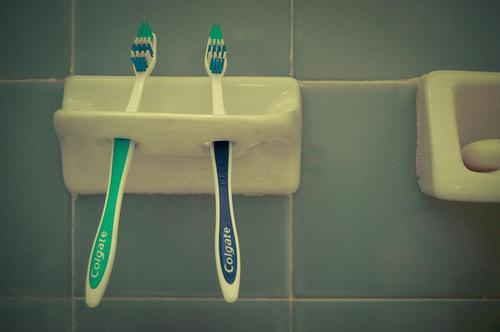What color is the grout?
Give a very brief answer. White. How many toothbrushes are there?
Keep it brief. 2. What brand are the brushes?
Quick response, please. Colgate. 